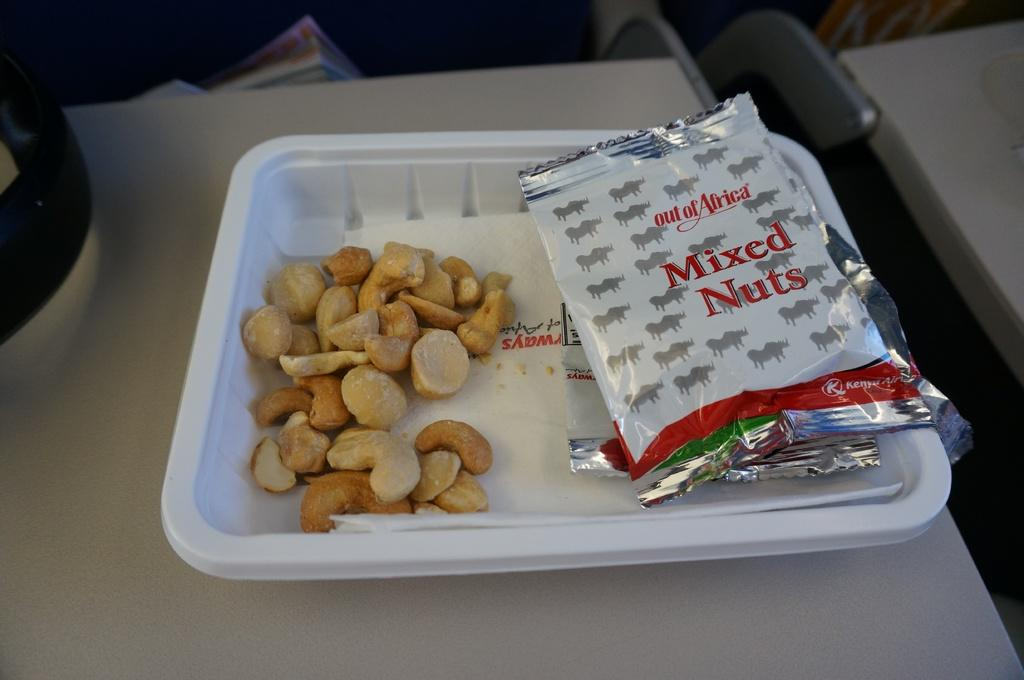What is the main piece of furniture in the image? There is a table in the image. What is placed on the table? There is a tray on the table. What types of nuts can be seen in the tray? Cashew nuts and almonds are present in the tray, along with other nuts. Is there any packaging visible in the image? Yes, there is a packet in the image. Can you tell me how many cats are sitting on the table in the image? There are no cats present in the image; it features a table with a tray of nuts and a packet. 